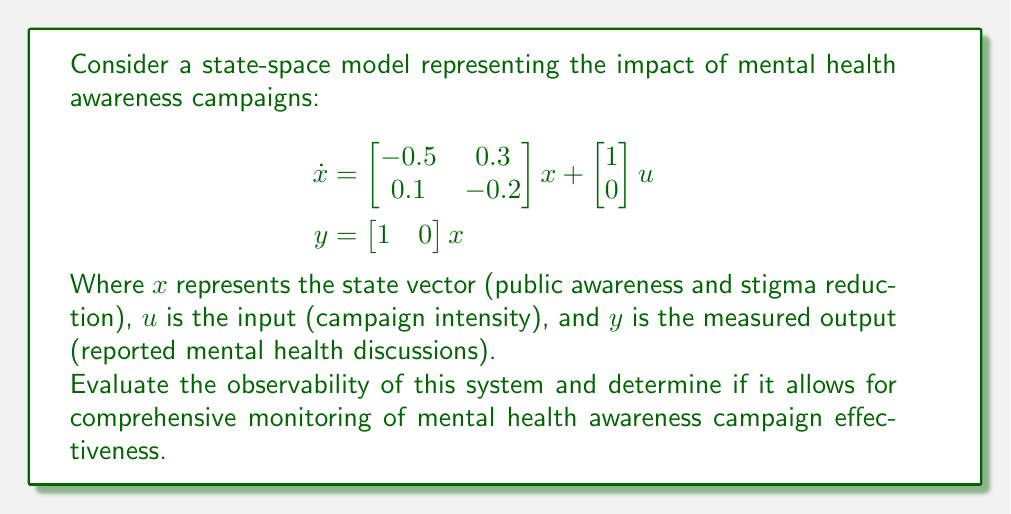Teach me how to tackle this problem. To evaluate the observability of the state-space model, we need to construct and analyze the observability matrix. The system is observable if the observability matrix has full rank.

Step 1: Identify the system matrices
A = $\begin{bmatrix} -0.5 & 0.3 \\ 0.1 & -0.2 \end{bmatrix}$
C = $\begin{bmatrix} 1 & 0 \end{bmatrix}$

Step 2: Construct the observability matrix
The observability matrix O is given by:
$$O = \begin{bmatrix} C \\ CA \end{bmatrix}$$

Calculating CA:
$$CA = \begin{bmatrix} 1 & 0 \end{bmatrix} \begin{bmatrix} -0.5 & 0.3 \\ 0.1 & -0.2 \end{bmatrix} = \begin{bmatrix} -0.5 & 0.3 \end{bmatrix}$$

Therefore, the observability matrix is:
$$O = \begin{bmatrix} 1 & 0 \\ -0.5 & 0.3 \end{bmatrix}$$

Step 3: Determine the rank of the observability matrix
To find the rank, we can calculate the determinant of O:

$$\det(O) = (1 \cdot 0.3) - (0 \cdot -0.5) = 0.3$$

Since the determinant is non-zero, the observability matrix has full rank (rank = 2).

Step 4: Interpret the result
The system is observable because the observability matrix has full rank. This means that all states (public awareness and stigma reduction) can be determined from the output measurements (reported mental health discussions) over time.

For mental health advocates, this implies that the effectiveness of awareness campaigns can be comprehensively monitored and evaluated using the available measurements, allowing for data-driven improvements in campaign strategies.
Answer: The system is observable (observability matrix has full rank). 